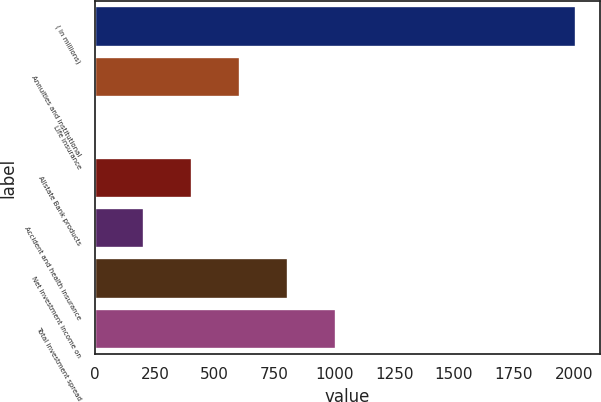Convert chart. <chart><loc_0><loc_0><loc_500><loc_500><bar_chart><fcel>( in millions)<fcel>Annuities and institutional<fcel>Life insurance<fcel>Allstate Bank products<fcel>Accident and health insurance<fcel>Net investment income on<fcel>Total investment spread<nl><fcel>2009<fcel>604.8<fcel>3<fcel>404.2<fcel>203.6<fcel>805.4<fcel>1006<nl></chart> 